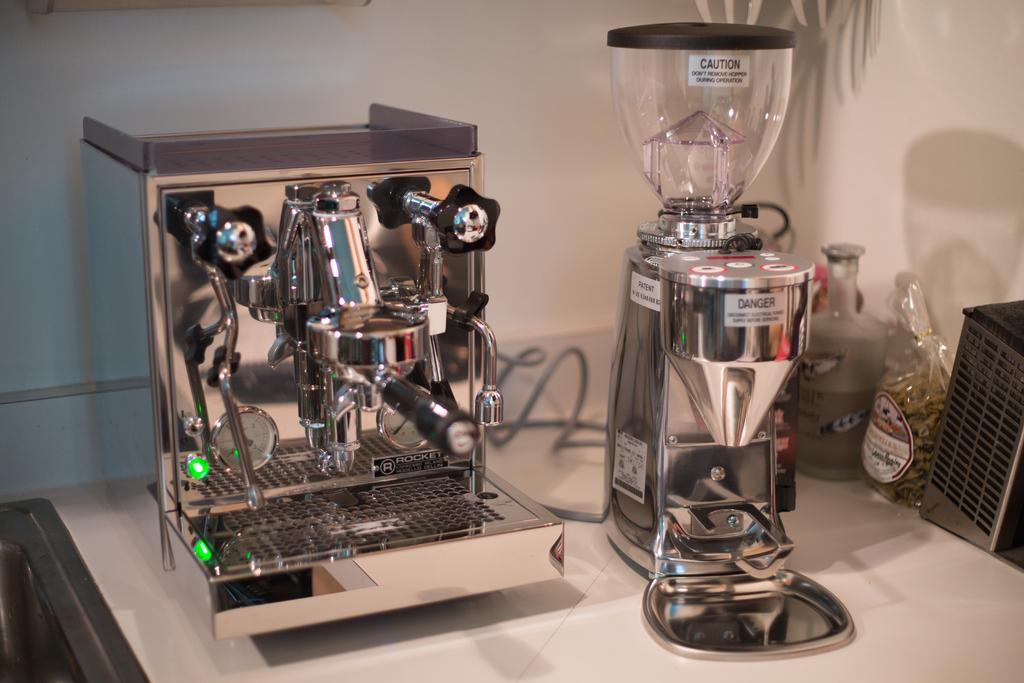Provide a one-sentence caption for the provided image. A coffee bean grinder, blender, and mixer on a table, all with "Danger" labels on them. 